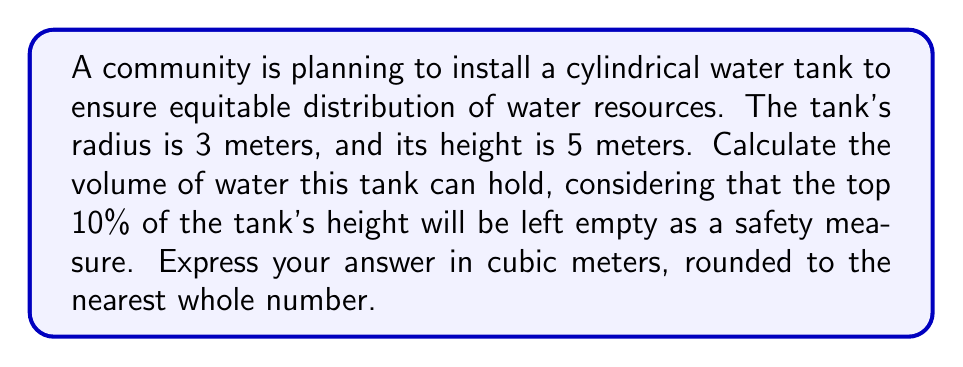Help me with this question. Let's approach this step-by-step:

1) First, we need to recall the formula for the volume of a cylinder:
   $$V = \pi r^2 h$$
   where $r$ is the radius and $h$ is the height.

2) We're given:
   $r = 3$ meters
   $h = 5$ meters

3) However, we're only using 90% of the height due to the safety measure. So our effective height is:
   $$h_{effective} = 5 \times 0.90 = 4.5$$ meters

4) Now, let's substitute these values into our volume formula:
   $$V = \pi \times 3^2 \times 4.5$$

5) Simplify:
   $$V = \pi \times 9 \times 4.5 = 40.5\pi$$

6) Calculate (using $\pi \approx 3.14159$):
   $$V \approx 40.5 \times 3.14159 \approx 127.23$$ cubic meters

7) Rounding to the nearest whole number:
   $$V \approx 127$$ cubic meters

This volume ensures that water can be distributed equitably among community members, without favoring the wealthy or powerful, while maintaining a safe operating level in the tank.
Answer: $127$ cubic meters 